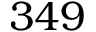Convert formula to latex. <formula><loc_0><loc_0><loc_500><loc_500>3 4 9</formula> 